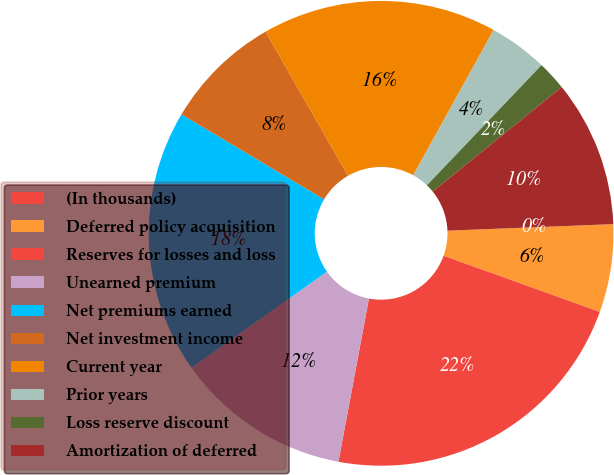Convert chart to OTSL. <chart><loc_0><loc_0><loc_500><loc_500><pie_chart><fcel>(In thousands)<fcel>Deferred policy acquisition<fcel>Reserves for losses and loss<fcel>Unearned premium<fcel>Net premiums earned<fcel>Net investment income<fcel>Current year<fcel>Prior years<fcel>Loss reserve discount<fcel>Amortization of deferred<nl><fcel>0.0%<fcel>6.12%<fcel>22.44%<fcel>12.24%<fcel>18.36%<fcel>8.16%<fcel>16.32%<fcel>4.08%<fcel>2.04%<fcel>10.2%<nl></chart> 